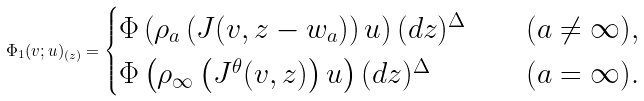Convert formula to latex. <formula><loc_0><loc_0><loc_500><loc_500>\Phi _ { 1 } ( v ; u ) _ { ( z ) } = \begin{cases} \Phi \left ( \rho _ { a } \left ( J ( v , z - w _ { a } ) \right ) u \right ) ( d z ) ^ { \Delta } & \quad ( a \neq \infty ) , \\ \Phi \left ( \rho _ { \infty } \left ( J ^ { \theta } ( v , z ) \right ) u \right ) ( d z ) ^ { \Delta } & \quad ( a = \infty ) . \end{cases}</formula> 